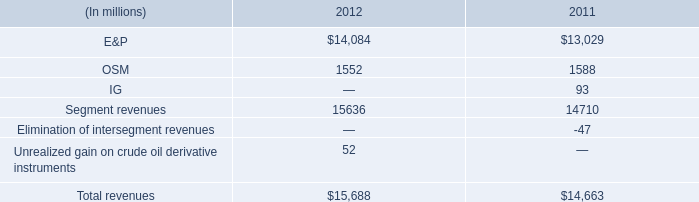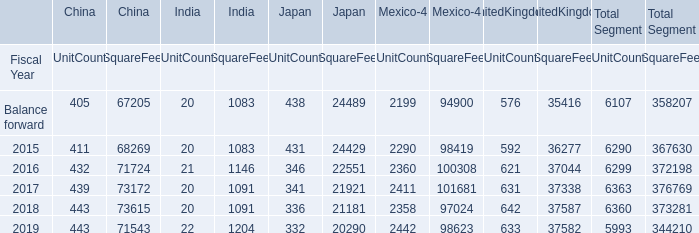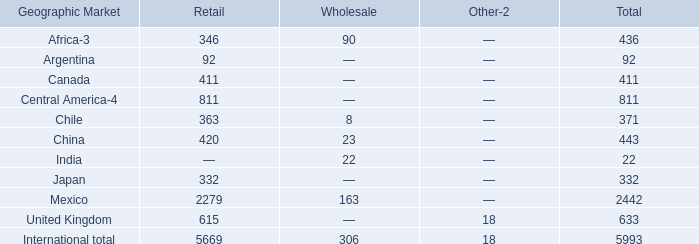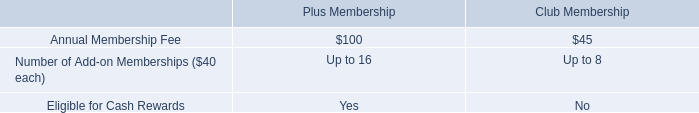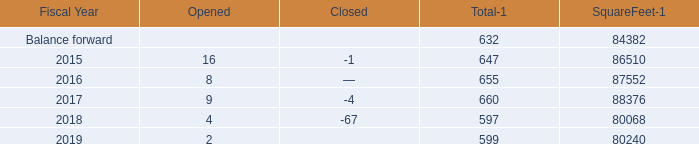what was the change in the effective income tax rate for continuing operations between in 2012 compared to 2011? 
Computations: (74 - 61)
Answer: 13.0. 